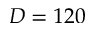<formula> <loc_0><loc_0><loc_500><loc_500>D = 1 2 0</formula> 